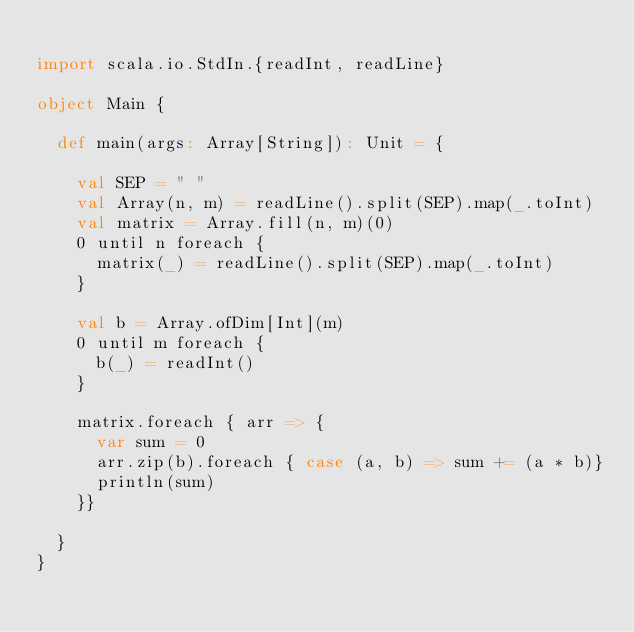Convert code to text. <code><loc_0><loc_0><loc_500><loc_500><_Scala_>
import scala.io.StdIn.{readInt, readLine}

object Main {

  def main(args: Array[String]): Unit = {

    val SEP = " "
    val Array(n, m) = readLine().split(SEP).map(_.toInt)
    val matrix = Array.fill(n, m)(0)
    0 until n foreach {
      matrix(_) = readLine().split(SEP).map(_.toInt)
    }

    val b = Array.ofDim[Int](m)
    0 until m foreach {
      b(_) = readInt()
    }

    matrix.foreach { arr => {
      var sum = 0
      arr.zip(b).foreach { case (a, b) => sum += (a * b)}
      println(sum)
    }}

  }
}

</code> 